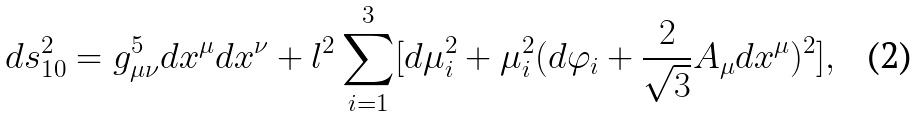<formula> <loc_0><loc_0><loc_500><loc_500>d s ^ { 2 } _ { 1 0 } = g ^ { 5 } _ { \mu \nu } d x ^ { \mu } d x ^ { \nu } + l ^ { 2 } \sum _ { i = 1 } ^ { 3 } [ d \mu _ { i } ^ { 2 } + \mu _ { i } ^ { 2 } ( d \varphi _ { i } + \frac { 2 } { \sqrt { 3 } } A _ { \mu } d x ^ { \mu } ) ^ { 2 } ] ,</formula> 